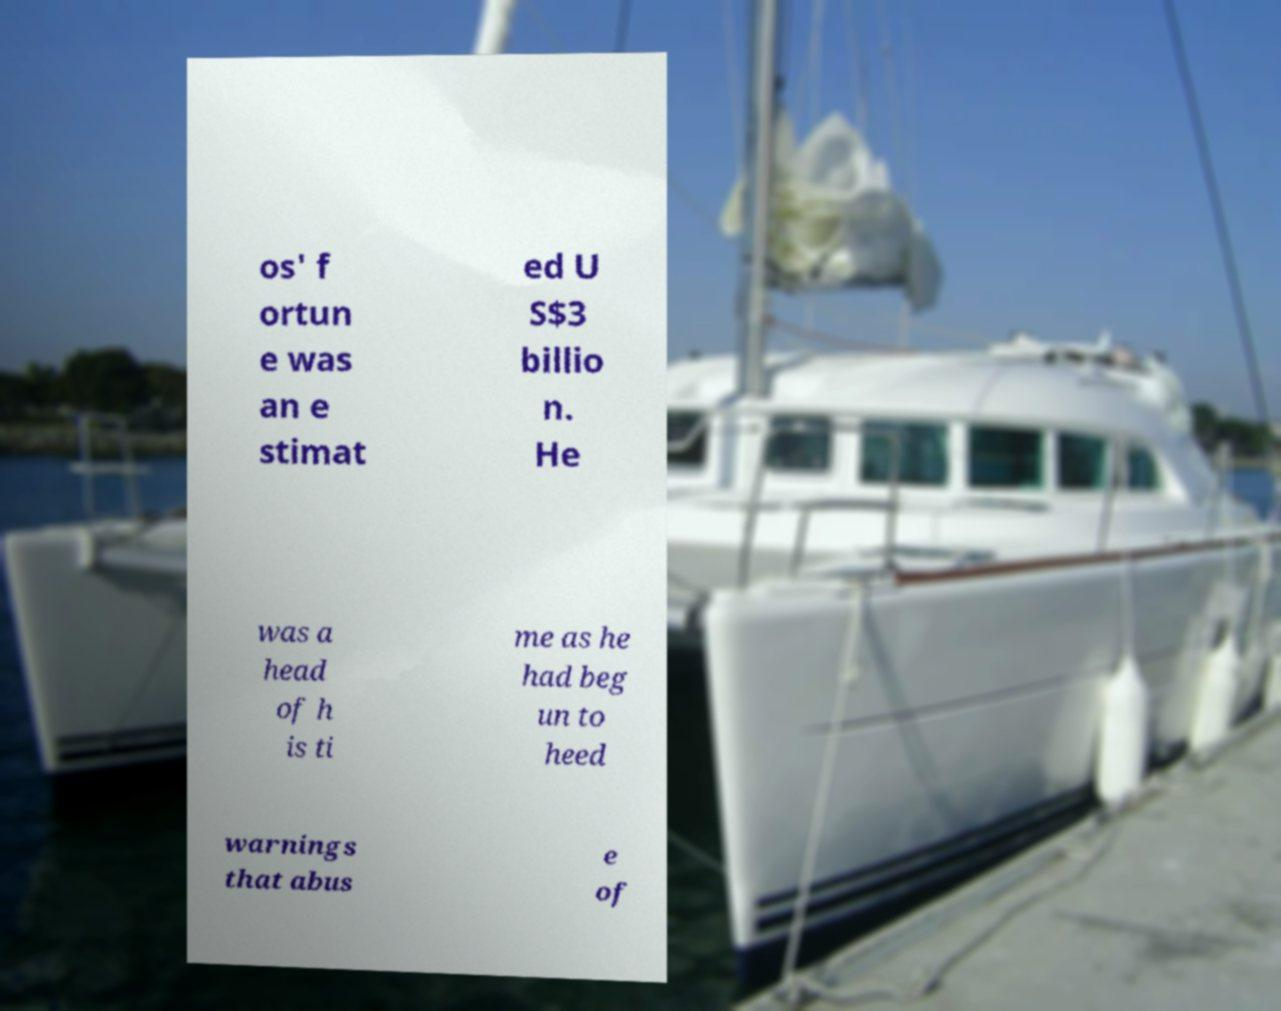For documentation purposes, I need the text within this image transcribed. Could you provide that? os' f ortun e was an e stimat ed U S$3 billio n. He was a head of h is ti me as he had beg un to heed warnings that abus e of 